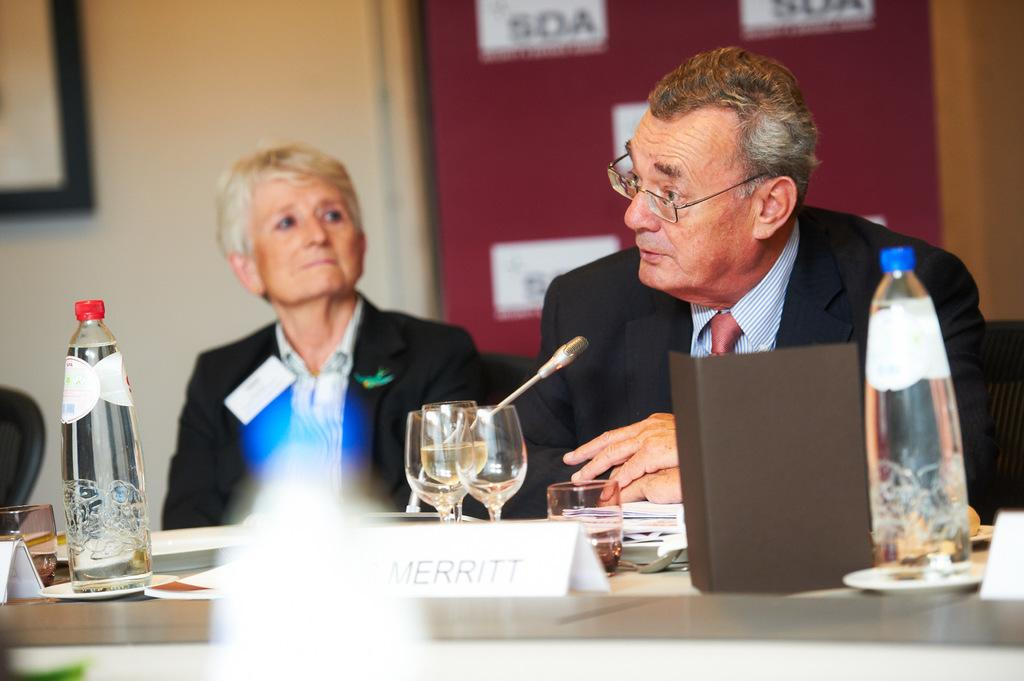How many people are present in the image? There are two people in the image, a man and a woman. What are the man and woman doing in the image? Both the man and woman are seated on chairs. What objects can be seen on the table in the image? There are bottles, glasses, and a microphone on the table. Who is using the microphone in the image? A man is speaking using the microphone. What type of powder is being used to clean the straw in the image? There is no straw or powder present in the image. 